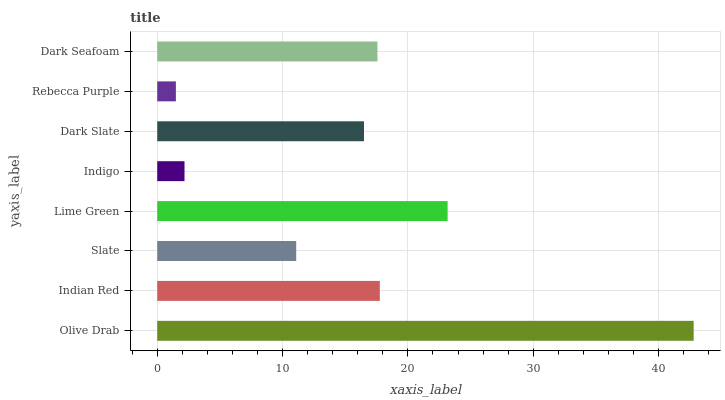Is Rebecca Purple the minimum?
Answer yes or no. Yes. Is Olive Drab the maximum?
Answer yes or no. Yes. Is Indian Red the minimum?
Answer yes or no. No. Is Indian Red the maximum?
Answer yes or no. No. Is Olive Drab greater than Indian Red?
Answer yes or no. Yes. Is Indian Red less than Olive Drab?
Answer yes or no. Yes. Is Indian Red greater than Olive Drab?
Answer yes or no. No. Is Olive Drab less than Indian Red?
Answer yes or no. No. Is Dark Seafoam the high median?
Answer yes or no. Yes. Is Dark Slate the low median?
Answer yes or no. Yes. Is Olive Drab the high median?
Answer yes or no. No. Is Lime Green the low median?
Answer yes or no. No. 